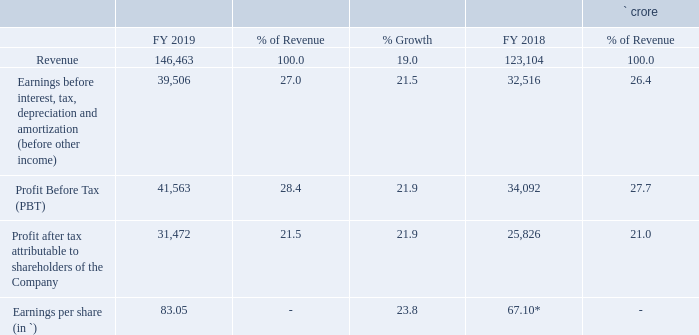5.0 FY 2019 Financial Performance and Analysis
The discussions in this section relate to the consolidated, Rupee-denominated financial results pertaining to the year that ended March 31, 2019. The financial statements of Tata Consultancy Services Limited and its subsidiaries (collectively referred to as ‘TCS’ or ‘the Company’) are prepared in accordance with the Indian Accounting Standards (referred to as ‘Ind AS’) prescribed under section 133 of the Companies Act, 2013, read with the Companies (Indian Accounting Standards) Rules, as amended from time to time. Significant accounting policies used in the preparation of the financial statements are disclosed in the notes to the consolidated financial statements.
The following table gives an overview of the consolidated financial results of the Company:
* EPS is adjusted for bonus issue
Which accounting standards are the company's financial statements based on? Indian accounting standards. What is the percentage growth in revenue from FY 2018 to FY 2019?
Answer scale should be: percent. 19. What is the EPS in FY 2019? 83.05. What is the amount of expenses incurred for FY 2019? 146,463-39,506 
Answer: 106957. What is the amount of tax expense for FY 2019? 41,563-31,472 
Answer: 10091. By what amount did the EPS increase from FY 2018 to FY 2019? 83.05-67.10 
Answer: 15.95. 